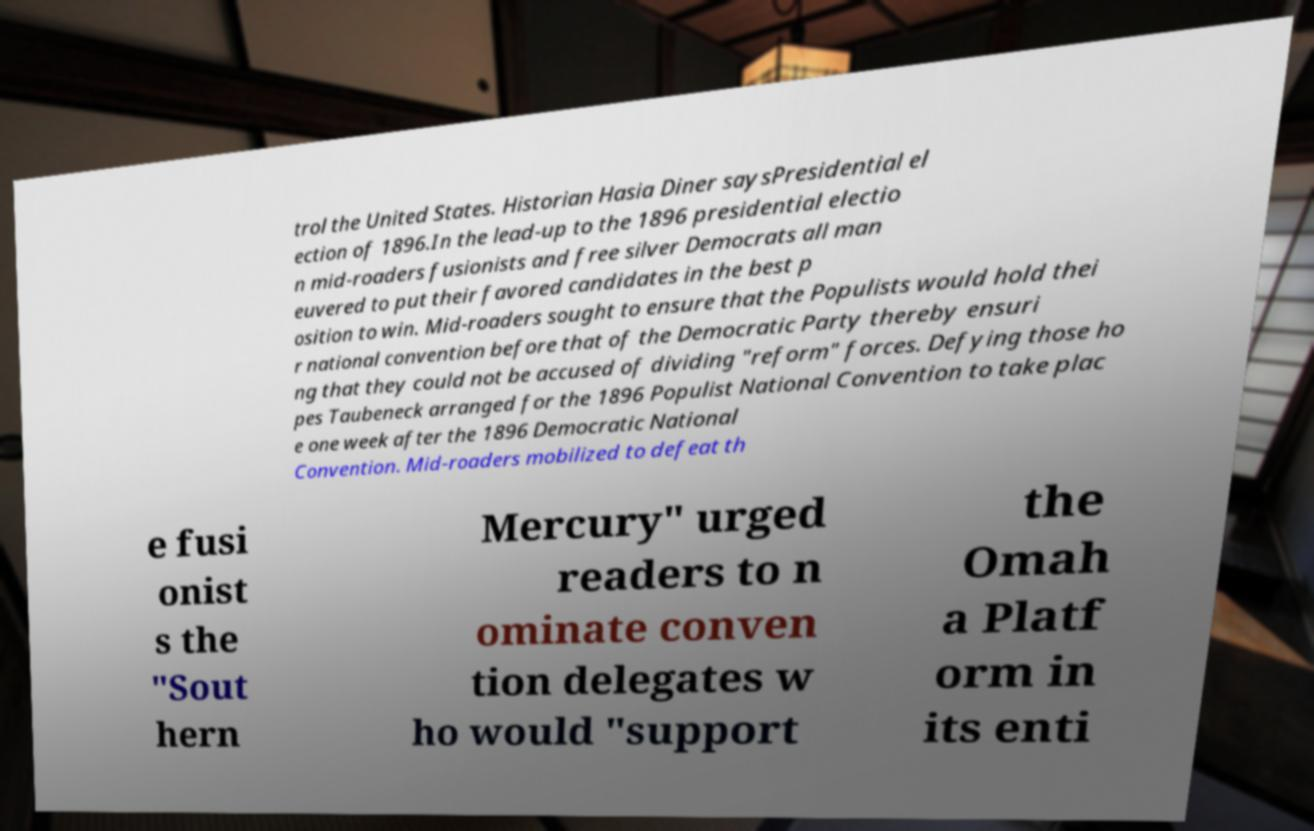Could you extract and type out the text from this image? trol the United States. Historian Hasia Diner saysPresidential el ection of 1896.In the lead-up to the 1896 presidential electio n mid-roaders fusionists and free silver Democrats all man euvered to put their favored candidates in the best p osition to win. Mid-roaders sought to ensure that the Populists would hold thei r national convention before that of the Democratic Party thereby ensuri ng that they could not be accused of dividing "reform" forces. Defying those ho pes Taubeneck arranged for the 1896 Populist National Convention to take plac e one week after the 1896 Democratic National Convention. Mid-roaders mobilized to defeat th e fusi onist s the "Sout hern Mercury" urged readers to n ominate conven tion delegates w ho would "support the Omah a Platf orm in its enti 